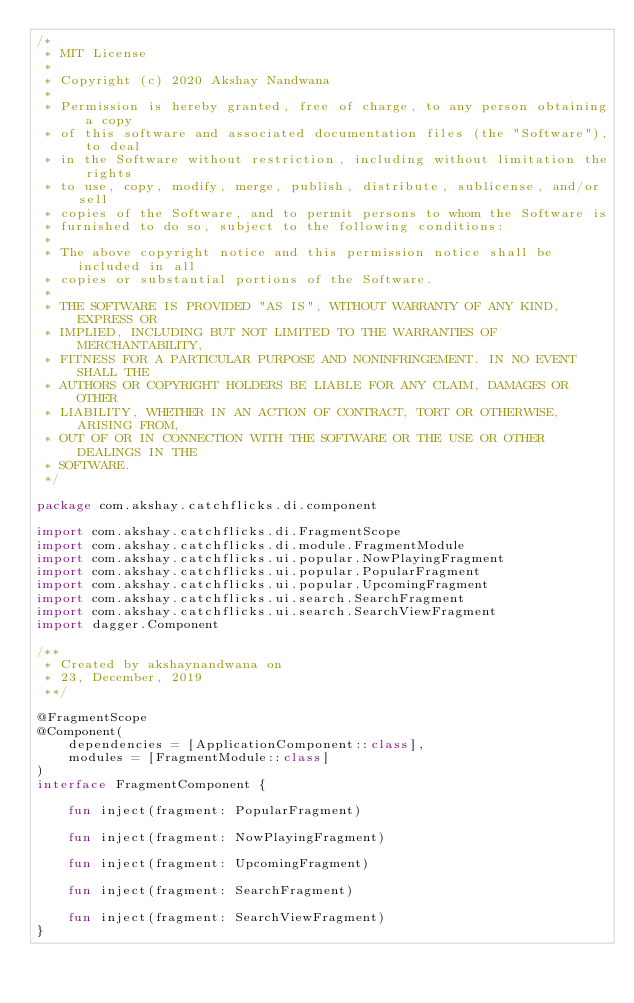Convert code to text. <code><loc_0><loc_0><loc_500><loc_500><_Kotlin_>/*
 * MIT License
 *
 * Copyright (c) 2020 Akshay Nandwana
 *
 * Permission is hereby granted, free of charge, to any person obtaining a copy
 * of this software and associated documentation files (the "Software"), to deal
 * in the Software without restriction, including without limitation the rights
 * to use, copy, modify, merge, publish, distribute, sublicense, and/or sell
 * copies of the Software, and to permit persons to whom the Software is
 * furnished to do so, subject to the following conditions:
 *
 * The above copyright notice and this permission notice shall be included in all
 * copies or substantial portions of the Software.
 *
 * THE SOFTWARE IS PROVIDED "AS IS", WITHOUT WARRANTY OF ANY KIND, EXPRESS OR
 * IMPLIED, INCLUDING BUT NOT LIMITED TO THE WARRANTIES OF MERCHANTABILITY,
 * FITNESS FOR A PARTICULAR PURPOSE AND NONINFRINGEMENT. IN NO EVENT SHALL THE
 * AUTHORS OR COPYRIGHT HOLDERS BE LIABLE FOR ANY CLAIM, DAMAGES OR OTHER
 * LIABILITY, WHETHER IN AN ACTION OF CONTRACT, TORT OR OTHERWISE, ARISING FROM,
 * OUT OF OR IN CONNECTION WITH THE SOFTWARE OR THE USE OR OTHER DEALINGS IN THE
 * SOFTWARE.
 */

package com.akshay.catchflicks.di.component

import com.akshay.catchflicks.di.FragmentScope
import com.akshay.catchflicks.di.module.FragmentModule
import com.akshay.catchflicks.ui.popular.NowPlayingFragment
import com.akshay.catchflicks.ui.popular.PopularFragment
import com.akshay.catchflicks.ui.popular.UpcomingFragment
import com.akshay.catchflicks.ui.search.SearchFragment
import com.akshay.catchflicks.ui.search.SearchViewFragment
import dagger.Component

/**
 * Created by akshaynandwana on
 * 23, December, 2019
 **/

@FragmentScope
@Component(
    dependencies = [ApplicationComponent::class],
    modules = [FragmentModule::class]
)
interface FragmentComponent {

    fun inject(fragment: PopularFragment)

    fun inject(fragment: NowPlayingFragment)

    fun inject(fragment: UpcomingFragment)

    fun inject(fragment: SearchFragment)

    fun inject(fragment: SearchViewFragment)
}</code> 